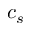Convert formula to latex. <formula><loc_0><loc_0><loc_500><loc_500>c _ { s }</formula> 